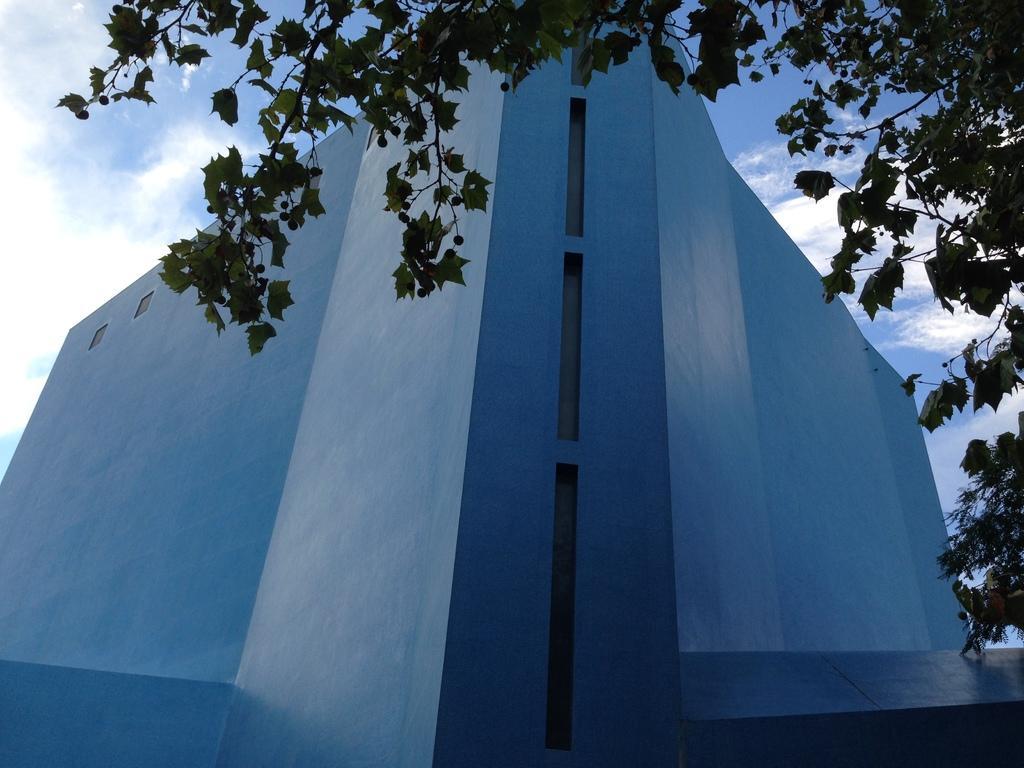Can you describe this image briefly? In this picture I can see a building, there are trees, and in the background there is sky. 